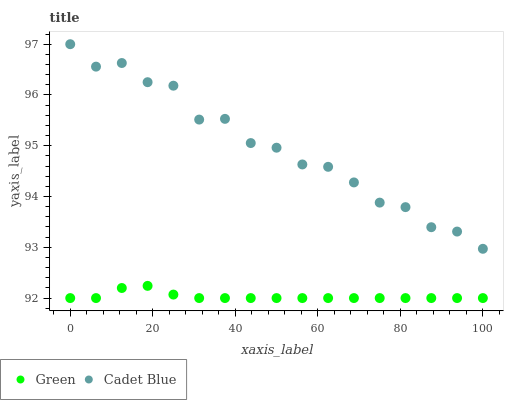Does Green have the minimum area under the curve?
Answer yes or no. Yes. Does Cadet Blue have the maximum area under the curve?
Answer yes or no. Yes. Does Green have the maximum area under the curve?
Answer yes or no. No. Is Green the smoothest?
Answer yes or no. Yes. Is Cadet Blue the roughest?
Answer yes or no. Yes. Is Green the roughest?
Answer yes or no. No. Does Green have the lowest value?
Answer yes or no. Yes. Does Cadet Blue have the highest value?
Answer yes or no. Yes. Does Green have the highest value?
Answer yes or no. No. Is Green less than Cadet Blue?
Answer yes or no. Yes. Is Cadet Blue greater than Green?
Answer yes or no. Yes. Does Green intersect Cadet Blue?
Answer yes or no. No. 